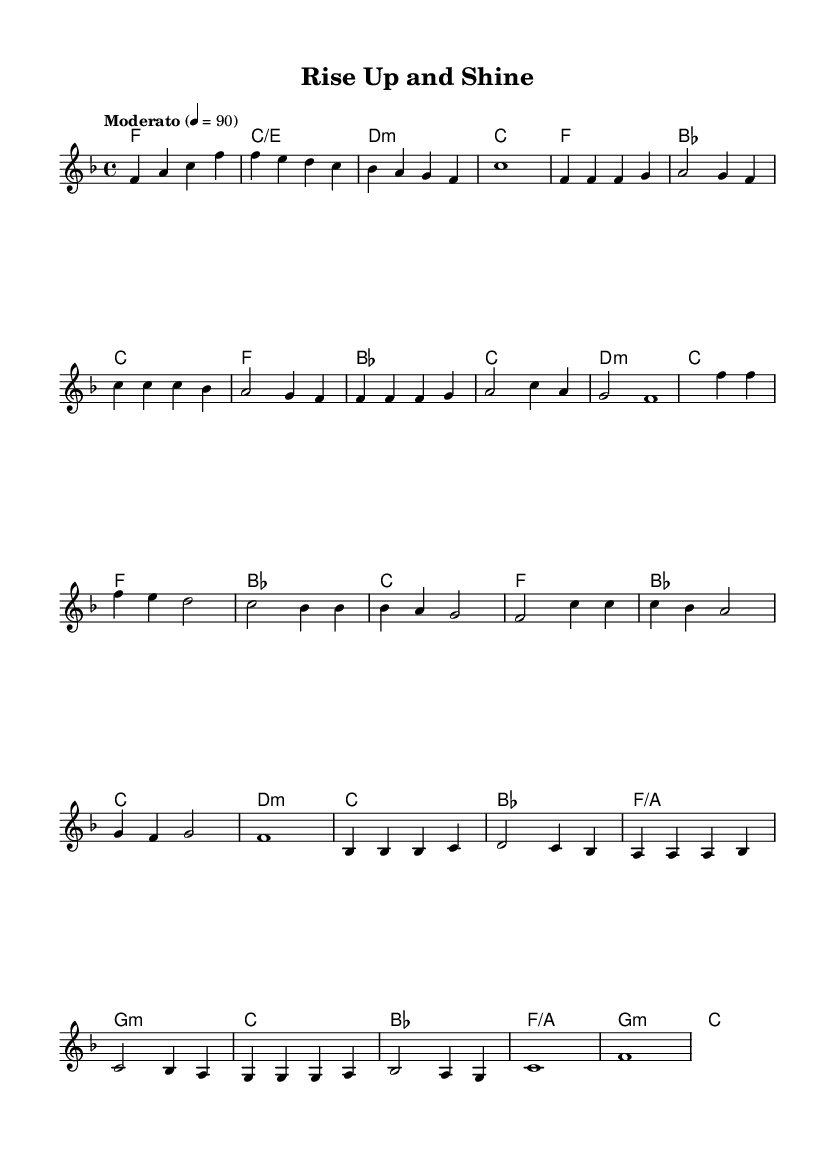What is the key signature of this music? The key signature is F major, which has one flat (B flat). This can be determined by looking at the key signature notation at the beginning of the sheet music.
Answer: F major What is the time signature of this music? The time signature is 4/4, which is indicated at the beginning of the piece. It specifies that there are four beats in each measure and the quarter note gets one beat.
Answer: 4/4 What is the tempo marking of this music? The tempo marking is "Moderato," which indicates a moderate speed, typically ranging from 98 to 109 beats per minute. This is found at the start of the sheet music indicating the desired speed of performance.
Answer: Moderato How many measures are in the chorus section? The chorus section consists of a total of four measures, which can be counted from the corresponding section in the score. Subsequent measures following the notation show the completion of this part.
Answer: 4 What is the main chord progression in the verse? The main chord progression in the verse is F - B flat - C - F. This can be observed through the harmonies provided alongside the melody. Each chord corresponds to a measure in the verse section.
Answer: F - B flat - C - F Which type of song structure does this piece follow? This piece follows a verse-chorus structure, a common format in soul music where verses alternate with the chorus. The layout of the melody and harmonies supports this classification through their repeated sections.
Answer: Verse-chorus What mood does the bridge section convey? The bridge section conveys a reflective mood, often characterized by the contrasting chords and melody that introduce a different emotional depth in the piece. This can be interpreted by analyzing the shifts in harmony and the melodic line in that section.
Answer: Reflective 